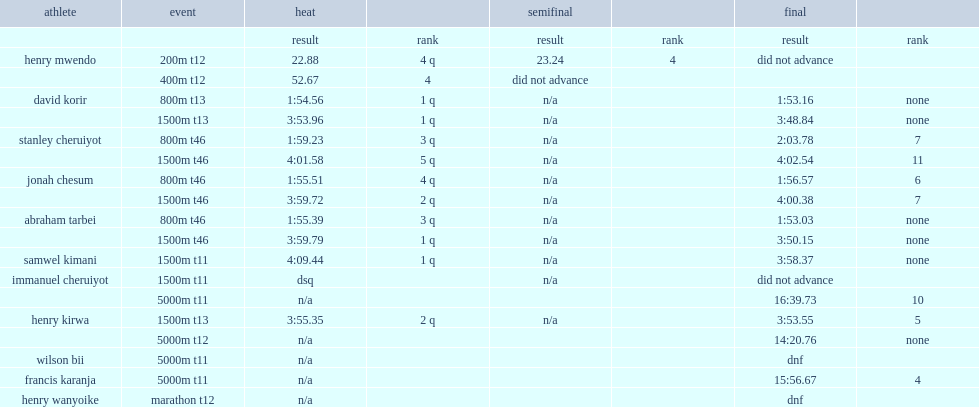What was the result that samwel kimani got in the 1,500m event? 3:58.37. 